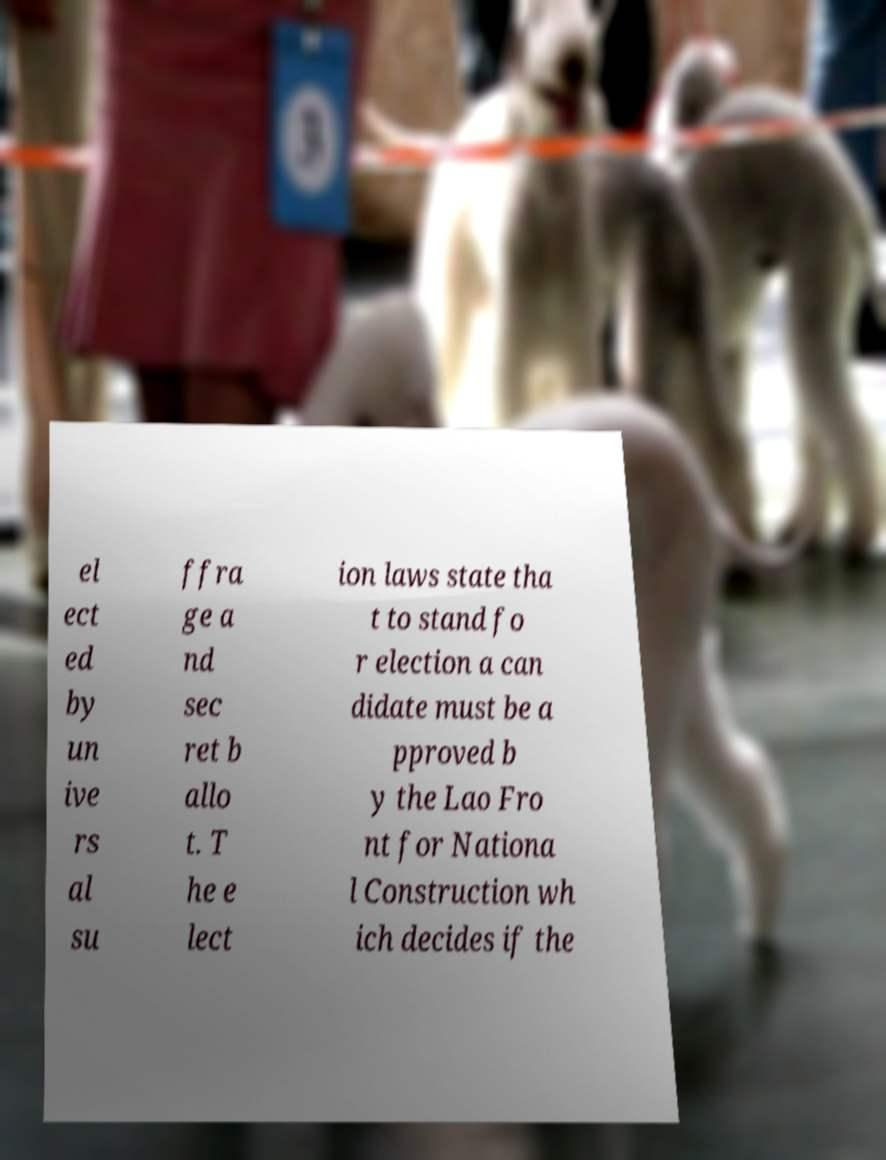There's text embedded in this image that I need extracted. Can you transcribe it verbatim? el ect ed by un ive rs al su ffra ge a nd sec ret b allo t. T he e lect ion laws state tha t to stand fo r election a can didate must be a pproved b y the Lao Fro nt for Nationa l Construction wh ich decides if the 